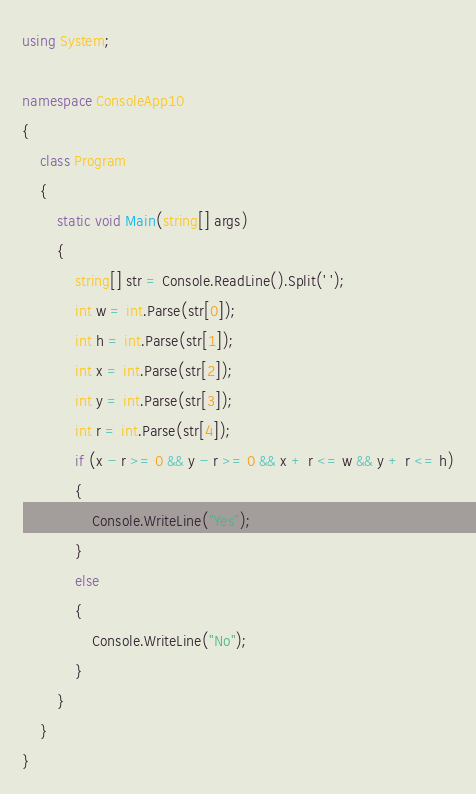Convert code to text. <code><loc_0><loc_0><loc_500><loc_500><_C#_>using System;

namespace ConsoleApp10
{
    class Program
    {
        static void Main(string[] args)
        {
            string[] str = Console.ReadLine().Split(' ');
            int w = int.Parse(str[0]);
            int h = int.Parse(str[1]);
            int x = int.Parse(str[2]);
            int y = int.Parse(str[3]);
            int r = int.Parse(str[4]);
            if (x - r >= 0 && y - r >= 0 && x + r <= w && y + r <= h)
            {
                Console.WriteLine("Yes");
            }
            else
            {
                Console.WriteLine("No");
            }
        }
    }
}</code> 